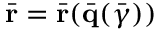<formula> <loc_0><loc_0><loc_500><loc_500>\bar { r } = \bar { r } ( \bar { q } ( \bar { \gamma } ) )</formula> 